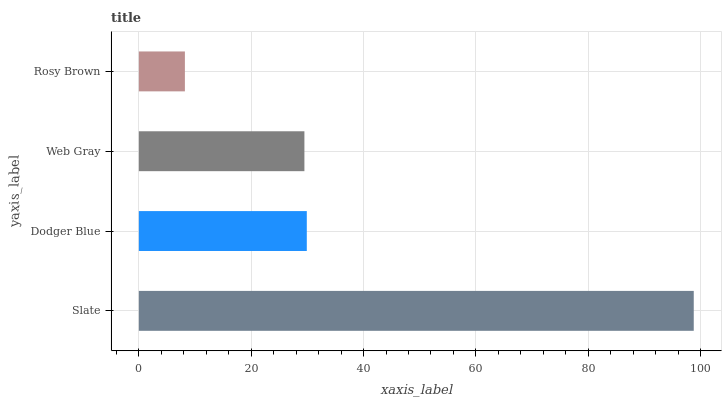Is Rosy Brown the minimum?
Answer yes or no. Yes. Is Slate the maximum?
Answer yes or no. Yes. Is Dodger Blue the minimum?
Answer yes or no. No. Is Dodger Blue the maximum?
Answer yes or no. No. Is Slate greater than Dodger Blue?
Answer yes or no. Yes. Is Dodger Blue less than Slate?
Answer yes or no. Yes. Is Dodger Blue greater than Slate?
Answer yes or no. No. Is Slate less than Dodger Blue?
Answer yes or no. No. Is Dodger Blue the high median?
Answer yes or no. Yes. Is Web Gray the low median?
Answer yes or no. Yes. Is Rosy Brown the high median?
Answer yes or no. No. Is Dodger Blue the low median?
Answer yes or no. No. 